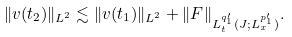<formula> <loc_0><loc_0><loc_500><loc_500>\| v ( t _ { 2 } ) \| _ { L ^ { 2 } } \lesssim \| v ( t _ { 1 } ) \| _ { L ^ { 2 } } + \| F \| _ { L ^ { { q _ { 1 } ^ { \prime } } } _ { t } ( J ; L ^ { p _ { 1 } ^ { \prime } } _ { x } ) } .</formula> 